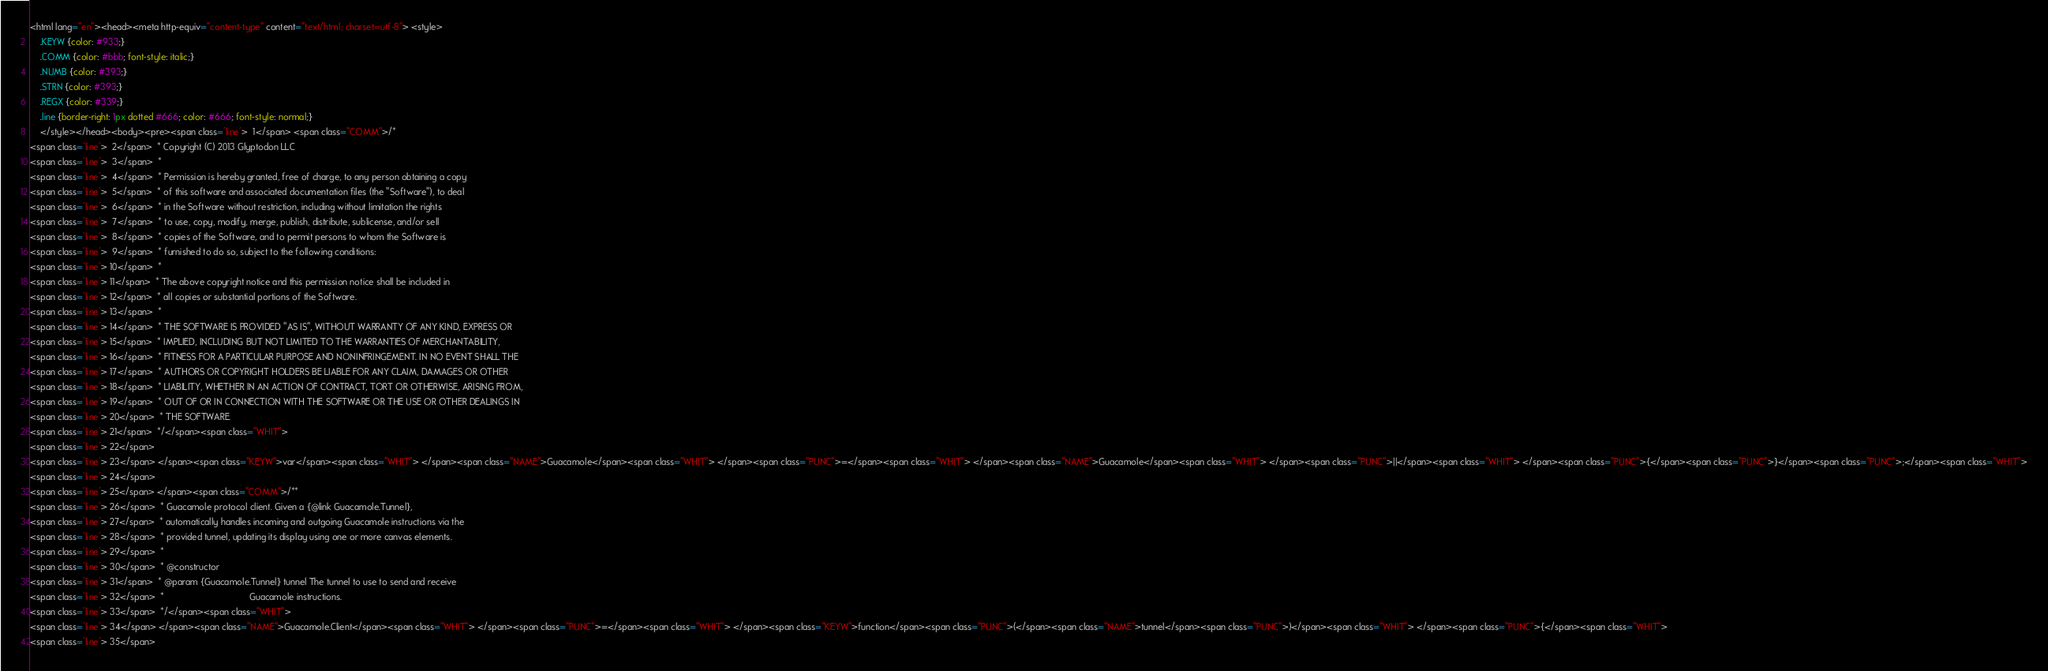Convert code to text. <code><loc_0><loc_0><loc_500><loc_500><_HTML_><html lang="en"><head><meta http-equiv="content-type" content="text/html; charset=utf-8"> <style>
	.KEYW {color: #933;}
	.COMM {color: #bbb; font-style: italic;}
	.NUMB {color: #393;}
	.STRN {color: #393;}
	.REGX {color: #339;}
	.line {border-right: 1px dotted #666; color: #666; font-style: normal;}
	</style></head><body><pre><span class='line'>  1</span> <span class="COMM">/*
<span class='line'>  2</span>  * Copyright (C) 2013 Glyptodon LLC
<span class='line'>  3</span>  *
<span class='line'>  4</span>  * Permission is hereby granted, free of charge, to any person obtaining a copy
<span class='line'>  5</span>  * of this software and associated documentation files (the "Software"), to deal
<span class='line'>  6</span>  * in the Software without restriction, including without limitation the rights
<span class='line'>  7</span>  * to use, copy, modify, merge, publish, distribute, sublicense, and/or sell
<span class='line'>  8</span>  * copies of the Software, and to permit persons to whom the Software is
<span class='line'>  9</span>  * furnished to do so, subject to the following conditions:
<span class='line'> 10</span>  *
<span class='line'> 11</span>  * The above copyright notice and this permission notice shall be included in
<span class='line'> 12</span>  * all copies or substantial portions of the Software.
<span class='line'> 13</span>  *
<span class='line'> 14</span>  * THE SOFTWARE IS PROVIDED "AS IS", WITHOUT WARRANTY OF ANY KIND, EXPRESS OR
<span class='line'> 15</span>  * IMPLIED, INCLUDING BUT NOT LIMITED TO THE WARRANTIES OF MERCHANTABILITY,
<span class='line'> 16</span>  * FITNESS FOR A PARTICULAR PURPOSE AND NONINFRINGEMENT. IN NO EVENT SHALL THE
<span class='line'> 17</span>  * AUTHORS OR COPYRIGHT HOLDERS BE LIABLE FOR ANY CLAIM, DAMAGES OR OTHER
<span class='line'> 18</span>  * LIABILITY, WHETHER IN AN ACTION OF CONTRACT, TORT OR OTHERWISE, ARISING FROM,
<span class='line'> 19</span>  * OUT OF OR IN CONNECTION WITH THE SOFTWARE OR THE USE OR OTHER DEALINGS IN
<span class='line'> 20</span>  * THE SOFTWARE.
<span class='line'> 21</span>  */</span><span class="WHIT">
<span class='line'> 22</span> 
<span class='line'> 23</span> </span><span class="KEYW">var</span><span class="WHIT"> </span><span class="NAME">Guacamole</span><span class="WHIT"> </span><span class="PUNC">=</span><span class="WHIT"> </span><span class="NAME">Guacamole</span><span class="WHIT"> </span><span class="PUNC">||</span><span class="WHIT"> </span><span class="PUNC">{</span><span class="PUNC">}</span><span class="PUNC">;</span><span class="WHIT">
<span class='line'> 24</span> 
<span class='line'> 25</span> </span><span class="COMM">/**
<span class='line'> 26</span>  * Guacamole protocol client. Given a {@link Guacamole.Tunnel},
<span class='line'> 27</span>  * automatically handles incoming and outgoing Guacamole instructions via the
<span class='line'> 28</span>  * provided tunnel, updating its display using one or more canvas elements.
<span class='line'> 29</span>  * 
<span class='line'> 30</span>  * @constructor
<span class='line'> 31</span>  * @param {Guacamole.Tunnel} tunnel The tunnel to use to send and receive
<span class='line'> 32</span>  *                                  Guacamole instructions.
<span class='line'> 33</span>  */</span><span class="WHIT">
<span class='line'> 34</span> </span><span class="NAME">Guacamole.Client</span><span class="WHIT"> </span><span class="PUNC">=</span><span class="WHIT"> </span><span class="KEYW">function</span><span class="PUNC">(</span><span class="NAME">tunnel</span><span class="PUNC">)</span><span class="WHIT"> </span><span class="PUNC">{</span><span class="WHIT">
<span class='line'> 35</span> </code> 